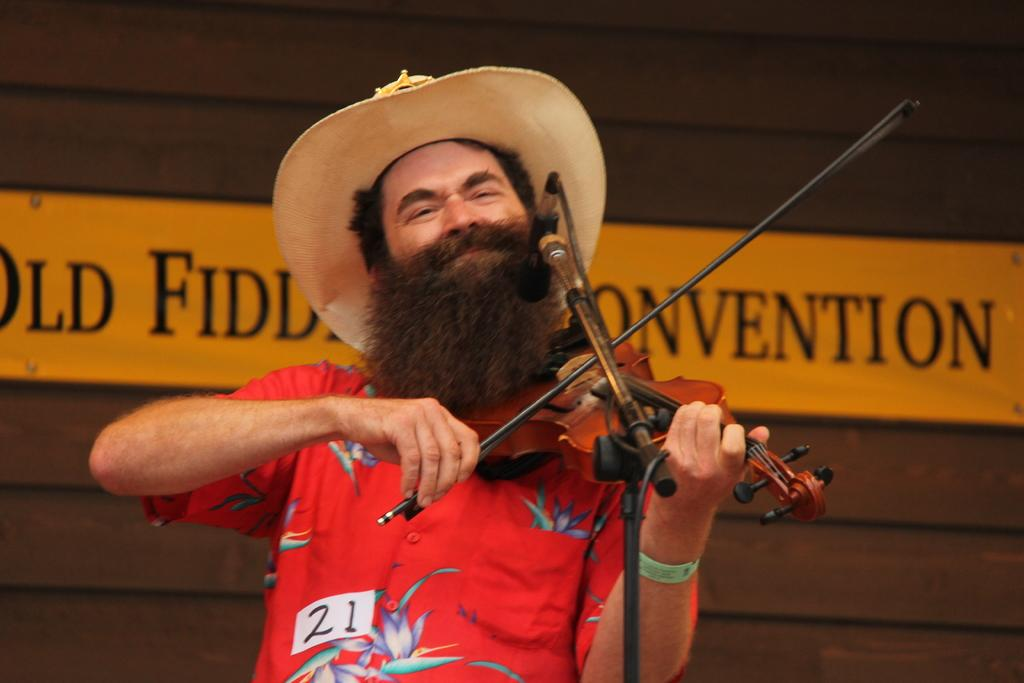What is the man in the image doing? The man is playing a violin. What is the man wearing on his upper body? The man is wearing a red color shirt. What object is present in front of the man? There is a microphone present in front of the man. What type of headwear is the man wearing? The man is wearing a hat. What type of debt is the man discussing with the representative in the image? There is no representative or discussion about debt in the image; the man is playing a violin. What shape is the circle that the man is drawing with the violin bow in the image? There is no circle being drawn with the violin bow in the image; the man is playing the violin. 